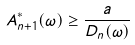<formula> <loc_0><loc_0><loc_500><loc_500>A ^ { * } _ { n + 1 } ( \omega ) \geq \frac { a } { D _ { n } ( \omega ) }</formula> 